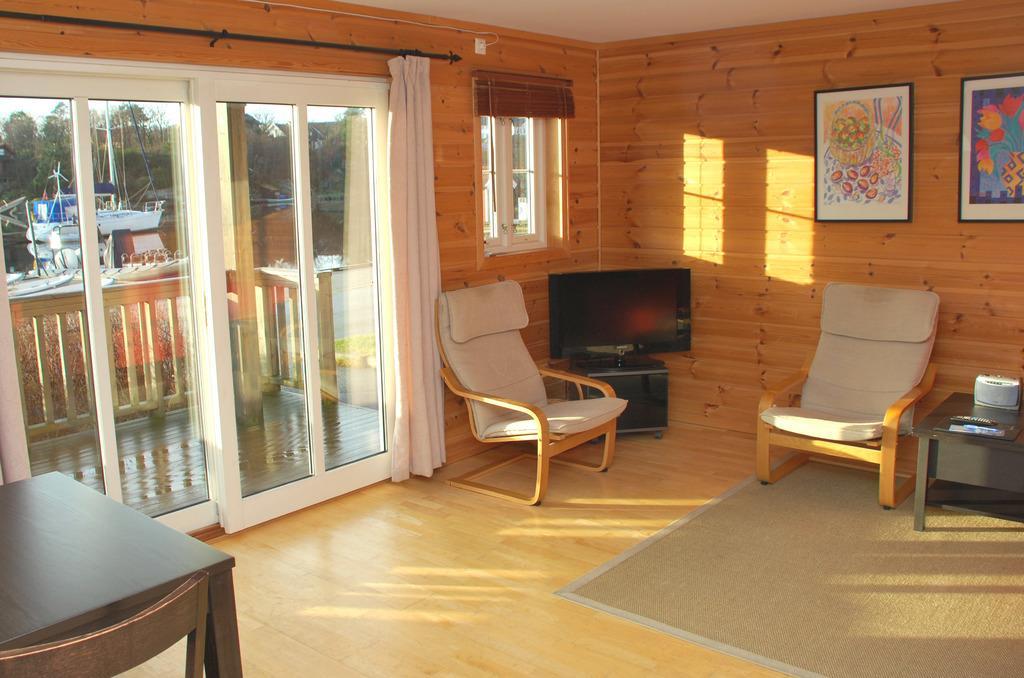Describe this image in one or two sentences. In this image we can see tables, chairs, television, carpet, photo frames on the wall, glass windows, window blinds, curtains, glass doors through which we can see the fence and boats is floating on the water and trees in the background. 